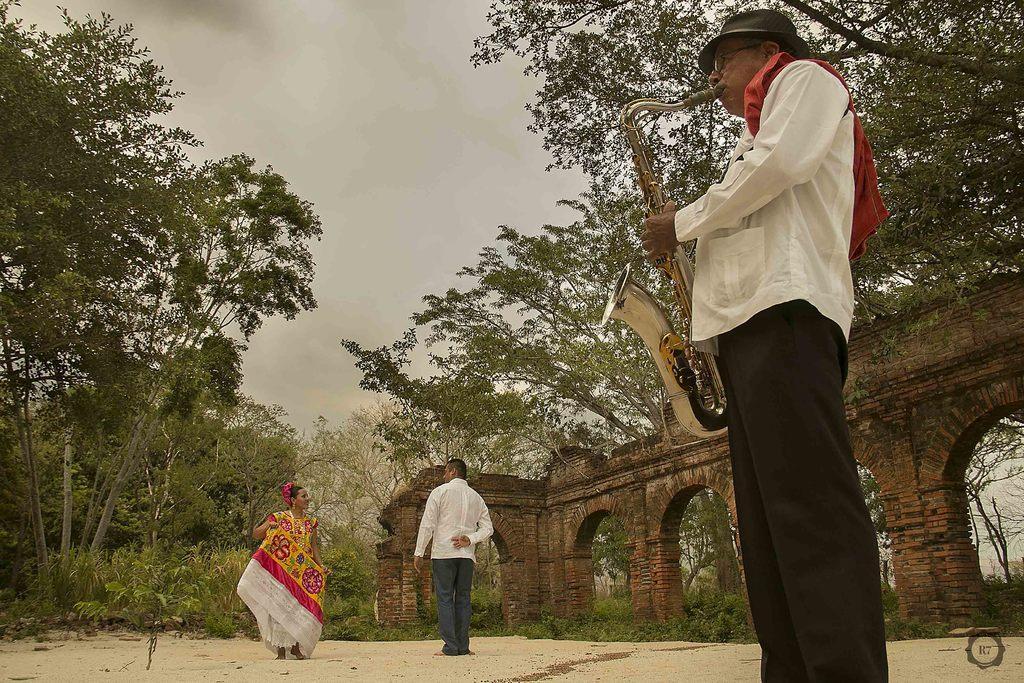Describe this image in one or two sentences. In this image, we can see three persons are standing. On the right side, a person is playing a musical instrument and wearing glasses and hat. Background we can see wall, trees, plants and sky. On the right side bottom corner, there is a logo. 